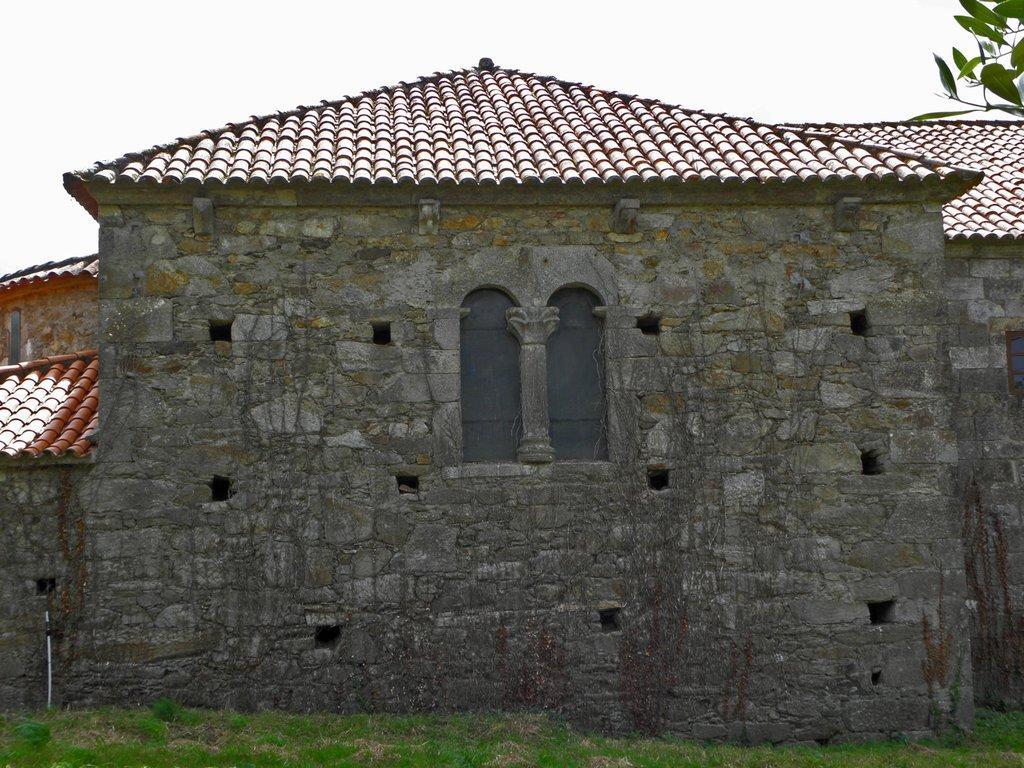In one or two sentences, can you explain what this image depicts? In this image, we can see a house. We can see the ground with some grass. We can also see a white colored object and some leaves on the top right corner. We can also see the sky. 